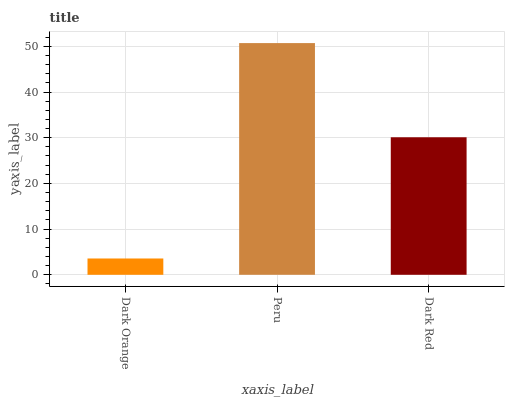Is Dark Orange the minimum?
Answer yes or no. Yes. Is Peru the maximum?
Answer yes or no. Yes. Is Dark Red the minimum?
Answer yes or no. No. Is Dark Red the maximum?
Answer yes or no. No. Is Peru greater than Dark Red?
Answer yes or no. Yes. Is Dark Red less than Peru?
Answer yes or no. Yes. Is Dark Red greater than Peru?
Answer yes or no. No. Is Peru less than Dark Red?
Answer yes or no. No. Is Dark Red the high median?
Answer yes or no. Yes. Is Dark Red the low median?
Answer yes or no. Yes. Is Peru the high median?
Answer yes or no. No. Is Dark Orange the low median?
Answer yes or no. No. 